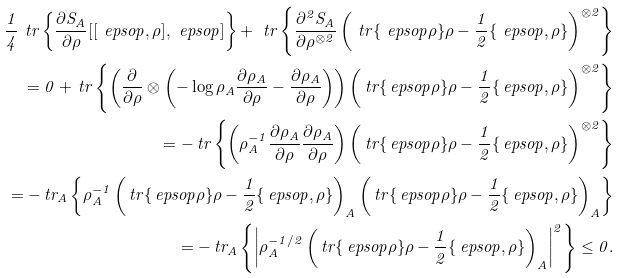Convert formula to latex. <formula><loc_0><loc_0><loc_500><loc_500>\frac { 1 } { 4 } \ t r \left \{ \frac { \partial S _ { A } } { \partial \rho } [ [ \ e p s o p , \rho ] , \ e p s o p ] \right \} + \ t r \left \{ \frac { \partial ^ { 2 } S _ { A } } { \partial \rho ^ { \otimes 2 } } \left ( \ t r \{ \ e p s o p \rho \} \rho - \frac { 1 } { 2 } \{ \ e p s o p , \rho \} \right ) ^ { \otimes 2 } \right \} \\ = 0 + \ t r \left \{ \left ( \frac { \partial } { \partial \rho } \otimes \left ( - \log { \rho _ { A } } \frac { \partial \rho _ { A } } { \partial \rho } - \frac { \partial \rho _ { A } } { \partial \rho } \right ) \right ) \left ( \ t r \{ \ e p s o p \rho \} \rho - \frac { 1 } { 2 } \{ \ e p s o p , \rho \} \right ) ^ { \otimes 2 } \right \} \\ = - \ t r \left \{ \left ( \rho _ { A } ^ { - 1 } \frac { \partial \rho _ { A } } { \partial \rho } \frac { \partial \rho _ { A } } { \partial \rho } \right ) \left ( \ t r \{ \ e p s o p \rho \} \rho - \frac { 1 } { 2 } \{ \ e p s o p , \rho \} \right ) ^ { \otimes 2 } \right \} \\ = - \ t r _ { A } \left \{ \rho _ { A } ^ { - 1 } \left ( \ t r \{ \ e p s o p \rho \} \rho - \frac { 1 } { 2 } \{ \ e p s o p , \rho \} \right ) _ { A } \left ( \ t r \{ \ e p s o p \rho \} \rho - \frac { 1 } { 2 } \{ \ e p s o p , \rho \} \right ) _ { A } \right \} \\ = - \ t r _ { A } \left \{ \left | \rho _ { A } ^ { - 1 / 2 } \left ( \ t r \{ \ e p s o p \rho \} \rho - \frac { 1 } { 2 } \{ \ e p s o p , \rho \} \right ) _ { A } \right | ^ { 2 } \right \} \leq 0 .</formula> 